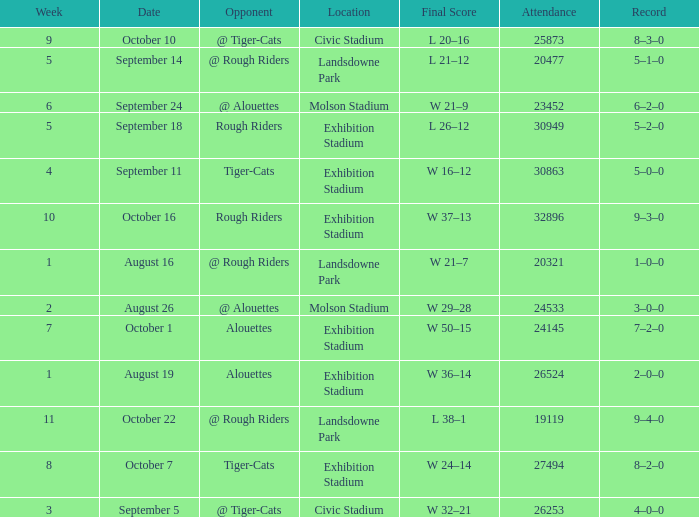How many values for attendance on the date of August 26? 1.0. 